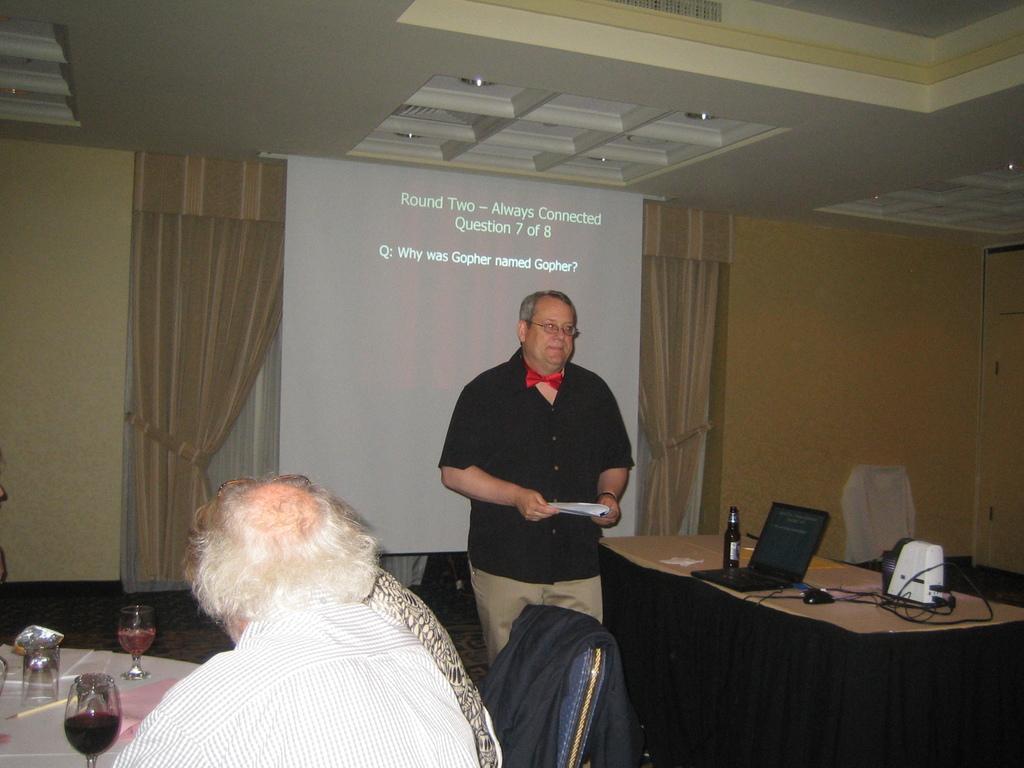In one or two sentences, can you explain what this image depicts? In this picture there is guy in front of a screen explaining and also few people sitting on the table with glasses on top of it. 